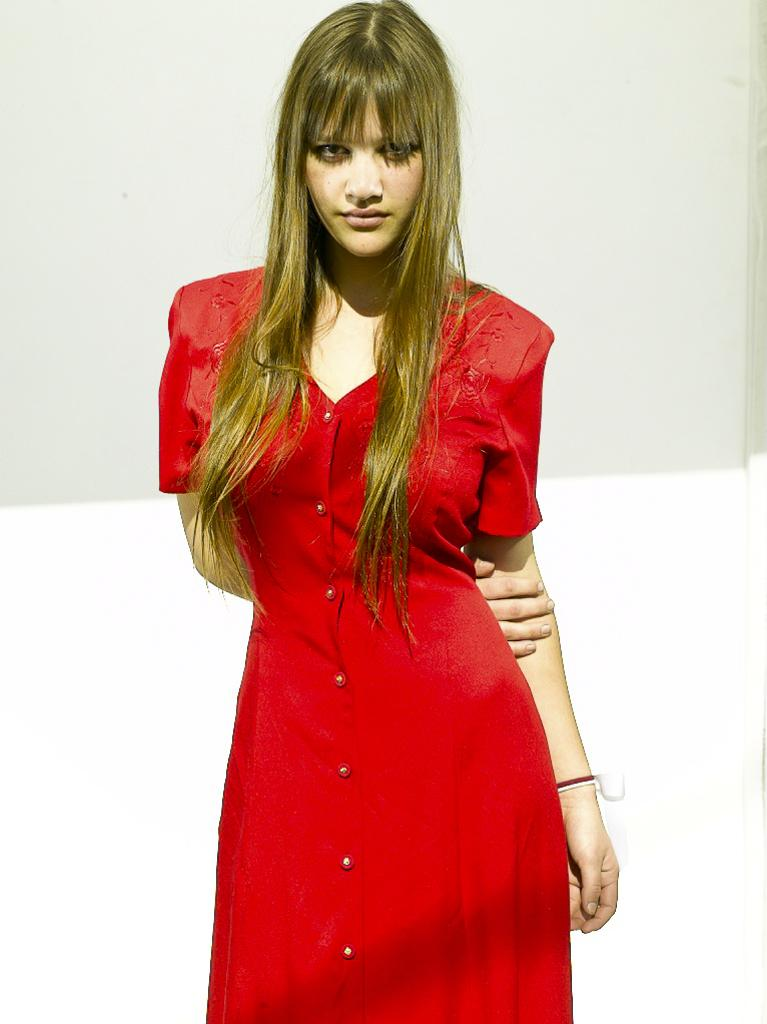Who is present in the image? There is a woman in the image. What is the woman doing in the image? The woman is standing. What is the woman wearing in the image? The woman is wearing a red dress. What accessory can be seen in the image? There is a hand band in the image. What is the color of the background in the image? The background of the image is white and pale gray in color. What holiday is being celebrated in the image? There is no indication of a holiday being celebrated in the image. What time of day is depicted in the image? The time of day cannot be determined from the image, as there are no specific clues or indicators present. 